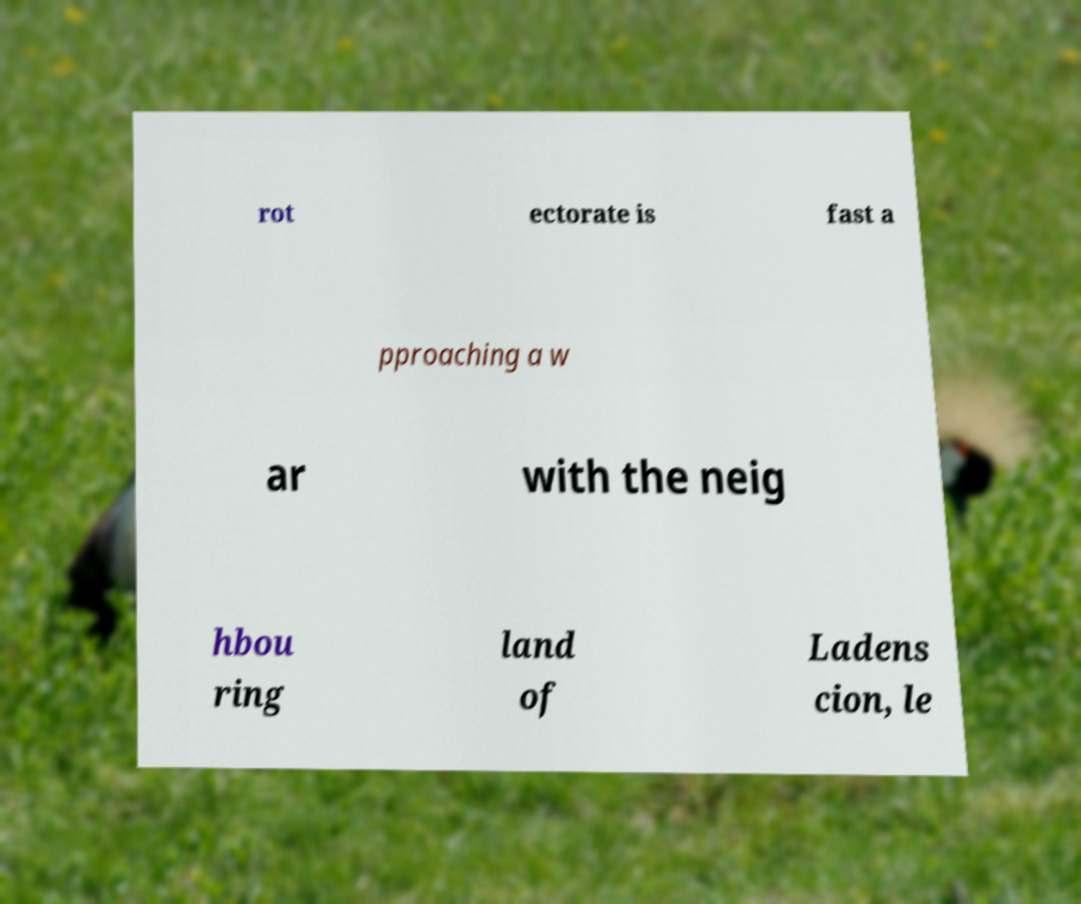Can you read and provide the text displayed in the image?This photo seems to have some interesting text. Can you extract and type it out for me? rot ectorate is fast a pproaching a w ar with the neig hbou ring land of Ladens cion, le 